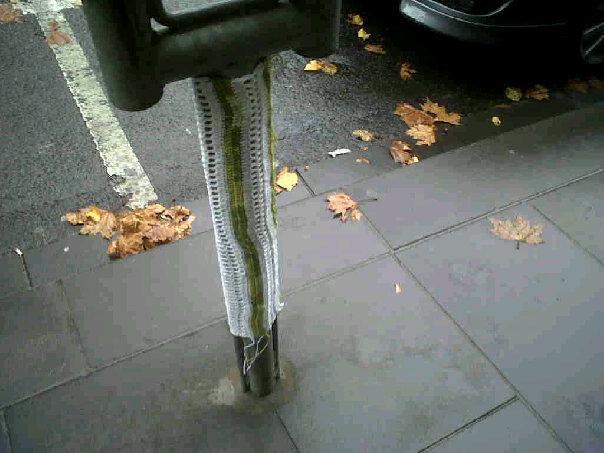What color are the leaves?
Answer briefly. Brown. What color is the line on the street?
Be succinct. White. Is this a snake skin?
Give a very brief answer. No. 